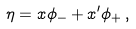Convert formula to latex. <formula><loc_0><loc_0><loc_500><loc_500>\eta = x \phi _ { - } + x ^ { \prime } \phi _ { + } \, ,</formula> 